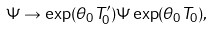Convert formula to latex. <formula><loc_0><loc_0><loc_500><loc_500>\Psi \rightarrow \exp ( \theta _ { 0 } T _ { 0 } ^ { \prime } ) \Psi \exp ( \theta _ { 0 } T _ { 0 } ) ,</formula> 